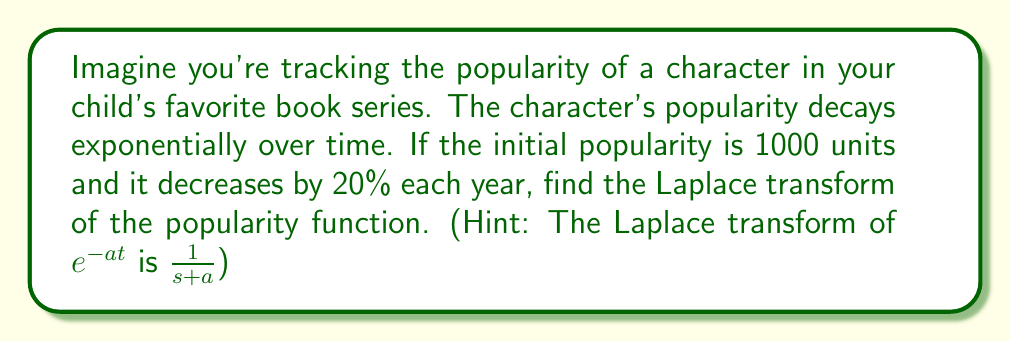What is the answer to this math problem? Let's break this down step-by-step:

1) First, we need to express the popularity as a function of time. If the popularity decreases by 20% each year, we can represent this as:

   $P(t) = 1000 \cdot (0.8)^t$

   where $t$ is time in years.

2) We can rewrite this using the exponential function:

   $P(t) = 1000 \cdot e^{\ln(0.8)t}$

3) Let's call $\ln(0.8) = -a$. So, $a = -\ln(0.8) \approx 0.223$

   Now our function looks like: $P(t) = 1000 \cdot e^{-at}$

4) The Laplace transform of $e^{-at}$ is $\frac{1}{s+a}$

5) The Laplace transform also has a scaling property: if $F(s)$ is the Laplace transform of $f(t)$, then the Laplace transform of $cf(t)$ is $cF(s)$

6) Therefore, the Laplace transform of our popularity function is:

   $\mathcal{L}\{P(t)\} = 1000 \cdot \frac{1}{s+a} = \frac{1000}{s+0.223}$

This gives us the Laplace transform of the popularity function.
Answer: $\mathcal{L}\{P(t)\} = \frac{1000}{s+0.223}$ 